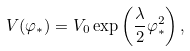Convert formula to latex. <formula><loc_0><loc_0><loc_500><loc_500>V ( \varphi _ { * } ) = V _ { 0 } \exp \left ( \frac { \lambda } { 2 } \varphi _ { * } ^ { 2 } \right ) ,</formula> 